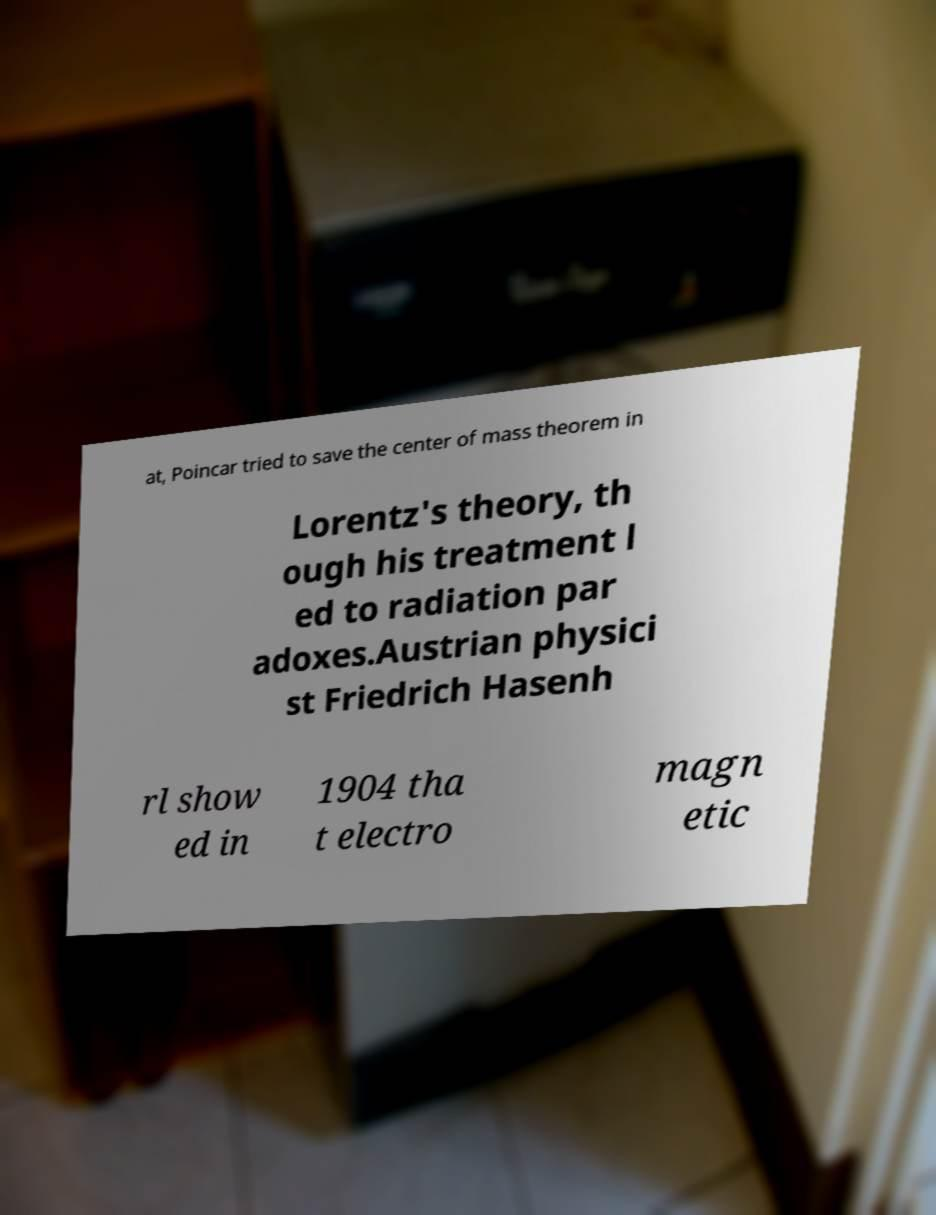Please read and relay the text visible in this image. What does it say? at, Poincar tried to save the center of mass theorem in Lorentz's theory, th ough his treatment l ed to radiation par adoxes.Austrian physici st Friedrich Hasenh rl show ed in 1904 tha t electro magn etic 